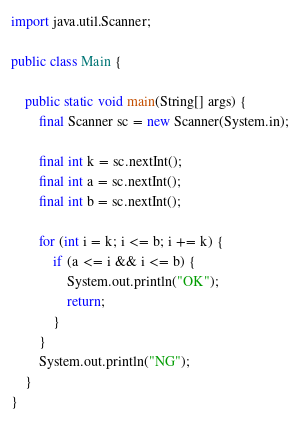<code> <loc_0><loc_0><loc_500><loc_500><_Java_>import java.util.Scanner;

public class Main {

    public static void main(String[] args) {
        final Scanner sc = new Scanner(System.in);

        final int k = sc.nextInt();
        final int a = sc.nextInt();
        final int b = sc.nextInt();

        for (int i = k; i <= b; i += k) {
            if (a <= i && i <= b) {
                System.out.println("OK");
                return;
            }
        }
        System.out.println("NG");
    }
}
</code> 